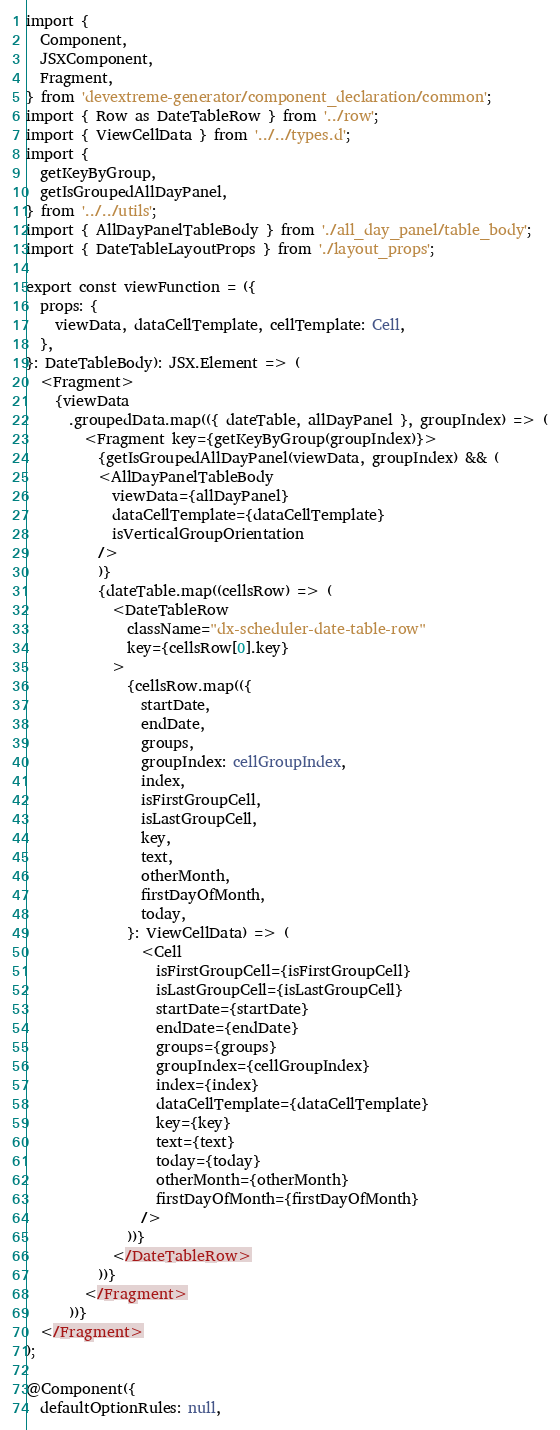Convert code to text. <code><loc_0><loc_0><loc_500><loc_500><_TypeScript_>import {
  Component,
  JSXComponent,
  Fragment,
} from 'devextreme-generator/component_declaration/common';
import { Row as DateTableRow } from '../row';
import { ViewCellData } from '../../types.d';
import {
  getKeyByGroup,
  getIsGroupedAllDayPanel,
} from '../../utils';
import { AllDayPanelTableBody } from './all_day_panel/table_body';
import { DateTableLayoutProps } from './layout_props';

export const viewFunction = ({
  props: {
    viewData, dataCellTemplate, cellTemplate: Cell,
  },
}: DateTableBody): JSX.Element => (
  <Fragment>
    {viewData
      .groupedData.map(({ dateTable, allDayPanel }, groupIndex) => (
        <Fragment key={getKeyByGroup(groupIndex)}>
          {getIsGroupedAllDayPanel(viewData, groupIndex) && (
          <AllDayPanelTableBody
            viewData={allDayPanel}
            dataCellTemplate={dataCellTemplate}
            isVerticalGroupOrientation
          />
          )}
          {dateTable.map((cellsRow) => (
            <DateTableRow
              className="dx-scheduler-date-table-row"
              key={cellsRow[0].key}
            >
              {cellsRow.map(({
                startDate,
                endDate,
                groups,
                groupIndex: cellGroupIndex,
                index,
                isFirstGroupCell,
                isLastGroupCell,
                key,
                text,
                otherMonth,
                firstDayOfMonth,
                today,
              }: ViewCellData) => (
                <Cell
                  isFirstGroupCell={isFirstGroupCell}
                  isLastGroupCell={isLastGroupCell}
                  startDate={startDate}
                  endDate={endDate}
                  groups={groups}
                  groupIndex={cellGroupIndex}
                  index={index}
                  dataCellTemplate={dataCellTemplate}
                  key={key}
                  text={text}
                  today={today}
                  otherMonth={otherMonth}
                  firstDayOfMonth={firstDayOfMonth}
                />
              ))}
            </DateTableRow>
          ))}
        </Fragment>
      ))}
  </Fragment>
);

@Component({
  defaultOptionRules: null,</code> 